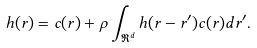Convert formula to latex. <formula><loc_0><loc_0><loc_500><loc_500>h ( { r } ) = c ( { r } ) + \rho \int _ { \Re ^ { d } } h ( { r } - { r } ^ { \prime } ) c ( { r } ) d { r } ^ { \prime } .</formula> 